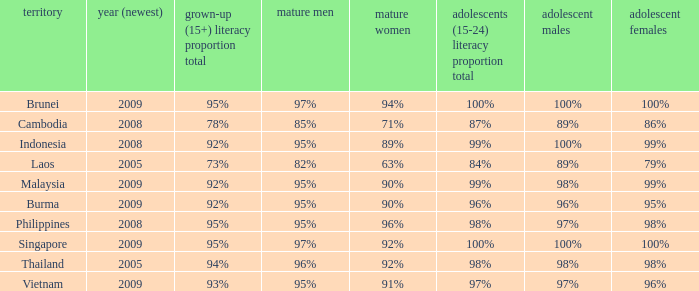Which country has a Youth (15-24) Literacy Rate Total of 100% and has an Adult Women Literacy rate of 92%? Singapore. 